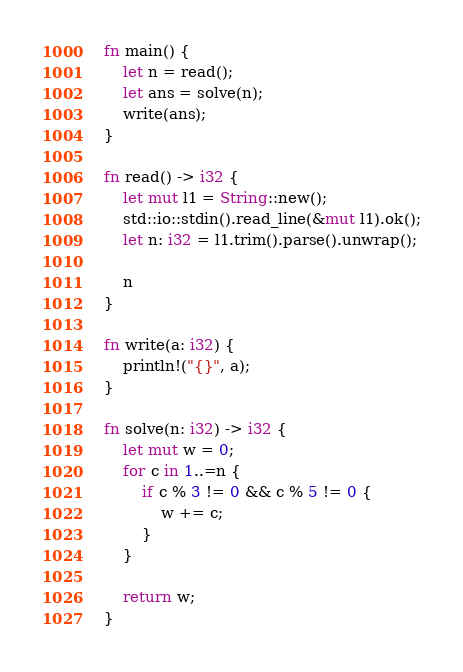Convert code to text. <code><loc_0><loc_0><loc_500><loc_500><_Rust_>fn main() {
    let n = read();
    let ans = solve(n);
    write(ans);
}

fn read() -> i32 {
    let mut l1 = String::new();
    std::io::stdin().read_line(&mut l1).ok();
    let n: i32 = l1.trim().parse().unwrap();

    n
}

fn write(a: i32) {
    println!("{}", a);
}

fn solve(n: i32) -> i32 {
    let mut w = 0;
    for c in 1..=n {
        if c % 3 != 0 && c % 5 != 0 {
            w += c;
        }
    }

    return w;
}</code> 